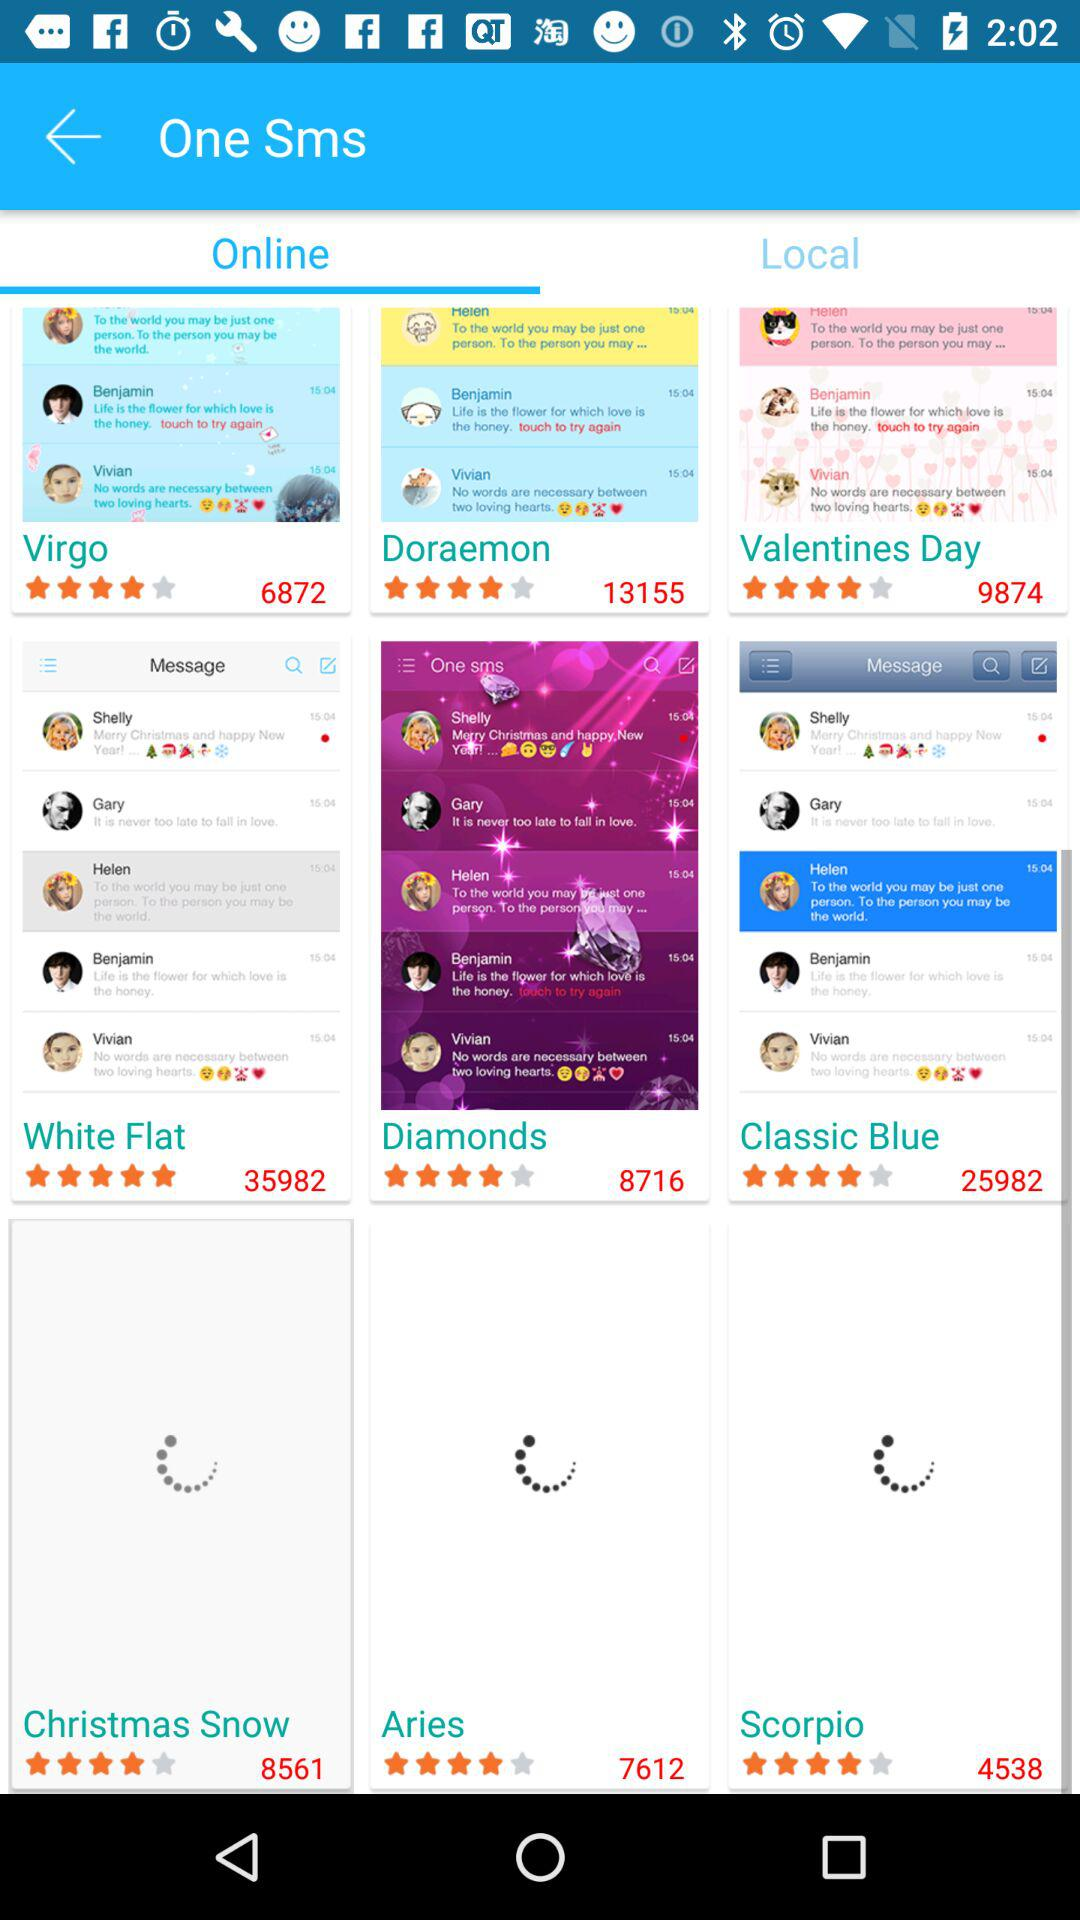Which tab is selected? The selected tab is "Online". 